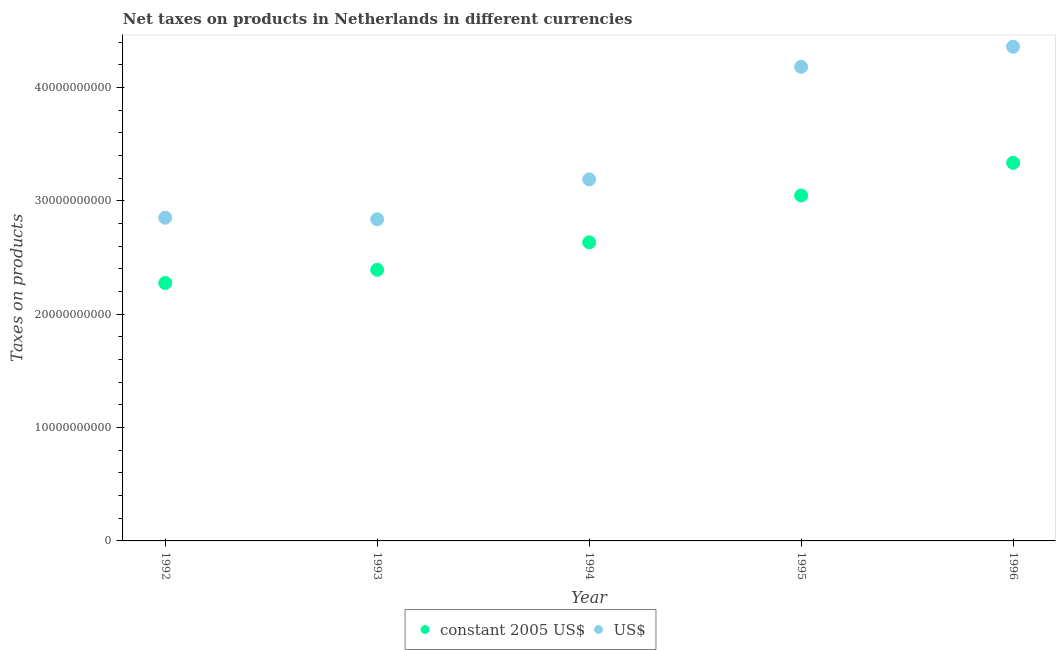What is the net taxes in constant 2005 us$ in 1992?
Your answer should be compact. 2.28e+1. Across all years, what is the maximum net taxes in constant 2005 us$?
Offer a very short reply. 3.33e+1. Across all years, what is the minimum net taxes in us$?
Provide a short and direct response. 2.84e+1. What is the total net taxes in constant 2005 us$ in the graph?
Provide a succinct answer. 1.37e+11. What is the difference between the net taxes in constant 2005 us$ in 1992 and that in 1993?
Your answer should be compact. -1.16e+09. What is the difference between the net taxes in us$ in 1995 and the net taxes in constant 2005 us$ in 1992?
Offer a very short reply. 1.91e+1. What is the average net taxes in us$ per year?
Offer a terse response. 3.48e+1. In the year 1994, what is the difference between the net taxes in constant 2005 us$ and net taxes in us$?
Offer a terse response. -5.55e+09. What is the ratio of the net taxes in constant 2005 us$ in 1993 to that in 1995?
Give a very brief answer. 0.78. What is the difference between the highest and the second highest net taxes in constant 2005 us$?
Offer a terse response. 2.88e+09. What is the difference between the highest and the lowest net taxes in us$?
Your answer should be compact. 1.52e+1. In how many years, is the net taxes in constant 2005 us$ greater than the average net taxes in constant 2005 us$ taken over all years?
Your response must be concise. 2. Does the net taxes in us$ monotonically increase over the years?
Your answer should be compact. No. Is the net taxes in us$ strictly less than the net taxes in constant 2005 us$ over the years?
Give a very brief answer. No. How many dotlines are there?
Your response must be concise. 2. How many years are there in the graph?
Keep it short and to the point. 5. Are the values on the major ticks of Y-axis written in scientific E-notation?
Your answer should be very brief. No. Does the graph contain grids?
Your answer should be compact. No. How many legend labels are there?
Make the answer very short. 2. How are the legend labels stacked?
Make the answer very short. Horizontal. What is the title of the graph?
Your response must be concise. Net taxes on products in Netherlands in different currencies. Does "Central government" appear as one of the legend labels in the graph?
Provide a short and direct response. No. What is the label or title of the Y-axis?
Provide a succinct answer. Taxes on products. What is the Taxes on products in constant 2005 US$ in 1992?
Your answer should be compact. 2.28e+1. What is the Taxes on products in US$ in 1992?
Offer a very short reply. 2.85e+1. What is the Taxes on products of constant 2005 US$ in 1993?
Provide a short and direct response. 2.39e+1. What is the Taxes on products of US$ in 1993?
Ensure brevity in your answer.  2.84e+1. What is the Taxes on products of constant 2005 US$ in 1994?
Provide a short and direct response. 2.63e+1. What is the Taxes on products in US$ in 1994?
Keep it short and to the point. 3.19e+1. What is the Taxes on products in constant 2005 US$ in 1995?
Keep it short and to the point. 3.05e+1. What is the Taxes on products in US$ in 1995?
Keep it short and to the point. 4.18e+1. What is the Taxes on products of constant 2005 US$ in 1996?
Provide a short and direct response. 3.33e+1. What is the Taxes on products of US$ in 1996?
Make the answer very short. 4.36e+1. Across all years, what is the maximum Taxes on products in constant 2005 US$?
Ensure brevity in your answer.  3.33e+1. Across all years, what is the maximum Taxes on products of US$?
Offer a terse response. 4.36e+1. Across all years, what is the minimum Taxes on products of constant 2005 US$?
Your answer should be very brief. 2.28e+1. Across all years, what is the minimum Taxes on products of US$?
Ensure brevity in your answer.  2.84e+1. What is the total Taxes on products of constant 2005 US$ in the graph?
Your answer should be compact. 1.37e+11. What is the total Taxes on products in US$ in the graph?
Your answer should be very brief. 1.74e+11. What is the difference between the Taxes on products in constant 2005 US$ in 1992 and that in 1993?
Provide a short and direct response. -1.16e+09. What is the difference between the Taxes on products of US$ in 1992 and that in 1993?
Keep it short and to the point. 1.37e+08. What is the difference between the Taxes on products in constant 2005 US$ in 1992 and that in 1994?
Give a very brief answer. -3.59e+09. What is the difference between the Taxes on products in US$ in 1992 and that in 1994?
Make the answer very short. -3.38e+09. What is the difference between the Taxes on products in constant 2005 US$ in 1992 and that in 1995?
Ensure brevity in your answer.  -7.72e+09. What is the difference between the Taxes on products in US$ in 1992 and that in 1995?
Ensure brevity in your answer.  -1.33e+1. What is the difference between the Taxes on products in constant 2005 US$ in 1992 and that in 1996?
Provide a short and direct response. -1.06e+1. What is the difference between the Taxes on products in US$ in 1992 and that in 1996?
Keep it short and to the point. -1.51e+1. What is the difference between the Taxes on products in constant 2005 US$ in 1993 and that in 1994?
Provide a short and direct response. -2.43e+09. What is the difference between the Taxes on products of US$ in 1993 and that in 1994?
Your response must be concise. -3.52e+09. What is the difference between the Taxes on products in constant 2005 US$ in 1993 and that in 1995?
Provide a succinct answer. -6.55e+09. What is the difference between the Taxes on products in US$ in 1993 and that in 1995?
Provide a succinct answer. -1.34e+1. What is the difference between the Taxes on products in constant 2005 US$ in 1993 and that in 1996?
Make the answer very short. -9.44e+09. What is the difference between the Taxes on products in US$ in 1993 and that in 1996?
Provide a short and direct response. -1.52e+1. What is the difference between the Taxes on products of constant 2005 US$ in 1994 and that in 1995?
Your answer should be compact. -4.13e+09. What is the difference between the Taxes on products of US$ in 1994 and that in 1995?
Give a very brief answer. -9.93e+09. What is the difference between the Taxes on products of constant 2005 US$ in 1994 and that in 1996?
Offer a very short reply. -7.01e+09. What is the difference between the Taxes on products in US$ in 1994 and that in 1996?
Provide a short and direct response. -1.17e+1. What is the difference between the Taxes on products in constant 2005 US$ in 1995 and that in 1996?
Make the answer very short. -2.88e+09. What is the difference between the Taxes on products of US$ in 1995 and that in 1996?
Your answer should be compact. -1.78e+09. What is the difference between the Taxes on products of constant 2005 US$ in 1992 and the Taxes on products of US$ in 1993?
Provide a succinct answer. -5.62e+09. What is the difference between the Taxes on products of constant 2005 US$ in 1992 and the Taxes on products of US$ in 1994?
Offer a terse response. -9.14e+09. What is the difference between the Taxes on products in constant 2005 US$ in 1992 and the Taxes on products in US$ in 1995?
Ensure brevity in your answer.  -1.91e+1. What is the difference between the Taxes on products of constant 2005 US$ in 1992 and the Taxes on products of US$ in 1996?
Offer a very short reply. -2.08e+1. What is the difference between the Taxes on products in constant 2005 US$ in 1993 and the Taxes on products in US$ in 1994?
Your response must be concise. -7.98e+09. What is the difference between the Taxes on products in constant 2005 US$ in 1993 and the Taxes on products in US$ in 1995?
Keep it short and to the point. -1.79e+1. What is the difference between the Taxes on products in constant 2005 US$ in 1993 and the Taxes on products in US$ in 1996?
Provide a short and direct response. -1.97e+1. What is the difference between the Taxes on products of constant 2005 US$ in 1994 and the Taxes on products of US$ in 1995?
Offer a very short reply. -1.55e+1. What is the difference between the Taxes on products of constant 2005 US$ in 1994 and the Taxes on products of US$ in 1996?
Your answer should be very brief. -1.73e+1. What is the difference between the Taxes on products in constant 2005 US$ in 1995 and the Taxes on products in US$ in 1996?
Your answer should be very brief. -1.31e+1. What is the average Taxes on products in constant 2005 US$ per year?
Give a very brief answer. 2.74e+1. What is the average Taxes on products of US$ per year?
Your answer should be very brief. 3.48e+1. In the year 1992, what is the difference between the Taxes on products of constant 2005 US$ and Taxes on products of US$?
Your answer should be compact. -5.76e+09. In the year 1993, what is the difference between the Taxes on products of constant 2005 US$ and Taxes on products of US$?
Offer a very short reply. -4.46e+09. In the year 1994, what is the difference between the Taxes on products of constant 2005 US$ and Taxes on products of US$?
Offer a very short reply. -5.55e+09. In the year 1995, what is the difference between the Taxes on products in constant 2005 US$ and Taxes on products in US$?
Provide a succinct answer. -1.13e+1. In the year 1996, what is the difference between the Taxes on products of constant 2005 US$ and Taxes on products of US$?
Give a very brief answer. -1.02e+1. What is the ratio of the Taxes on products in constant 2005 US$ in 1992 to that in 1993?
Your response must be concise. 0.95. What is the ratio of the Taxes on products in US$ in 1992 to that in 1993?
Provide a short and direct response. 1. What is the ratio of the Taxes on products in constant 2005 US$ in 1992 to that in 1994?
Give a very brief answer. 0.86. What is the ratio of the Taxes on products of US$ in 1992 to that in 1994?
Ensure brevity in your answer.  0.89. What is the ratio of the Taxes on products of constant 2005 US$ in 1992 to that in 1995?
Your answer should be compact. 0.75. What is the ratio of the Taxes on products of US$ in 1992 to that in 1995?
Your answer should be very brief. 0.68. What is the ratio of the Taxes on products of constant 2005 US$ in 1992 to that in 1996?
Give a very brief answer. 0.68. What is the ratio of the Taxes on products of US$ in 1992 to that in 1996?
Offer a terse response. 0.65. What is the ratio of the Taxes on products in constant 2005 US$ in 1993 to that in 1994?
Provide a short and direct response. 0.91. What is the ratio of the Taxes on products in US$ in 1993 to that in 1994?
Your response must be concise. 0.89. What is the ratio of the Taxes on products of constant 2005 US$ in 1993 to that in 1995?
Give a very brief answer. 0.78. What is the ratio of the Taxes on products of US$ in 1993 to that in 1995?
Keep it short and to the point. 0.68. What is the ratio of the Taxes on products of constant 2005 US$ in 1993 to that in 1996?
Provide a succinct answer. 0.72. What is the ratio of the Taxes on products of US$ in 1993 to that in 1996?
Make the answer very short. 0.65. What is the ratio of the Taxes on products of constant 2005 US$ in 1994 to that in 1995?
Your answer should be compact. 0.86. What is the ratio of the Taxes on products in US$ in 1994 to that in 1995?
Give a very brief answer. 0.76. What is the ratio of the Taxes on products of constant 2005 US$ in 1994 to that in 1996?
Ensure brevity in your answer.  0.79. What is the ratio of the Taxes on products in US$ in 1994 to that in 1996?
Provide a succinct answer. 0.73. What is the ratio of the Taxes on products in constant 2005 US$ in 1995 to that in 1996?
Offer a terse response. 0.91. What is the ratio of the Taxes on products in US$ in 1995 to that in 1996?
Make the answer very short. 0.96. What is the difference between the highest and the second highest Taxes on products of constant 2005 US$?
Give a very brief answer. 2.88e+09. What is the difference between the highest and the second highest Taxes on products of US$?
Make the answer very short. 1.78e+09. What is the difference between the highest and the lowest Taxes on products of constant 2005 US$?
Provide a short and direct response. 1.06e+1. What is the difference between the highest and the lowest Taxes on products in US$?
Provide a short and direct response. 1.52e+1. 